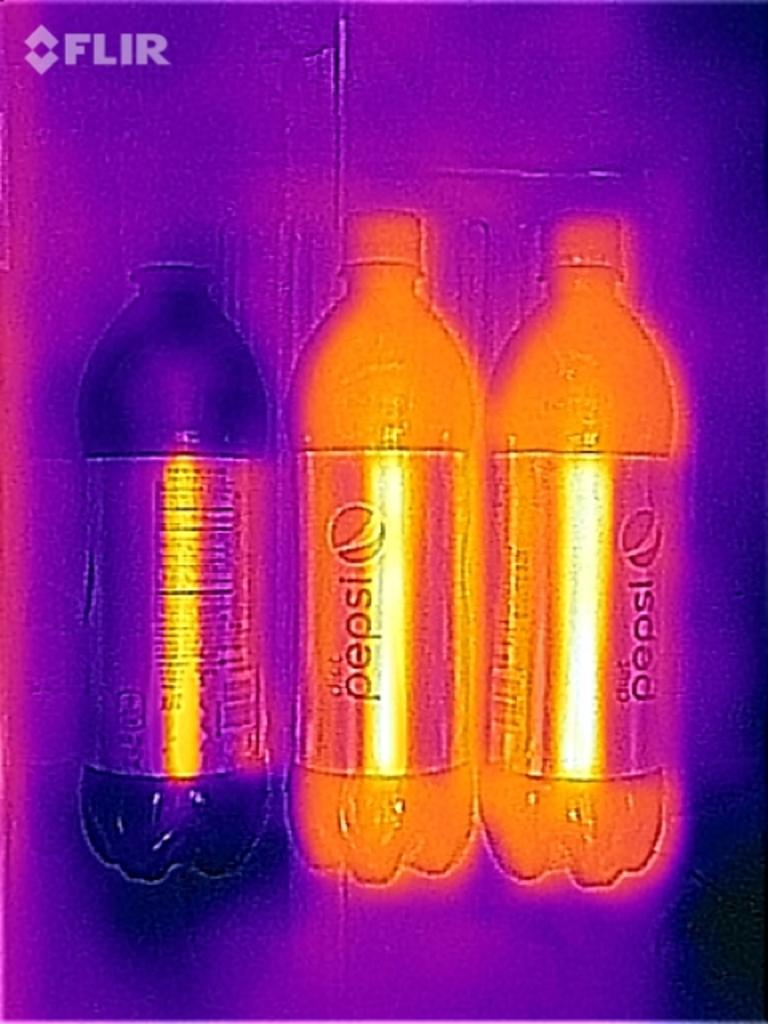<image>
Summarize the visual content of the image. three glowing bottles of pepsi against a purple background with word FLIR at top corner 